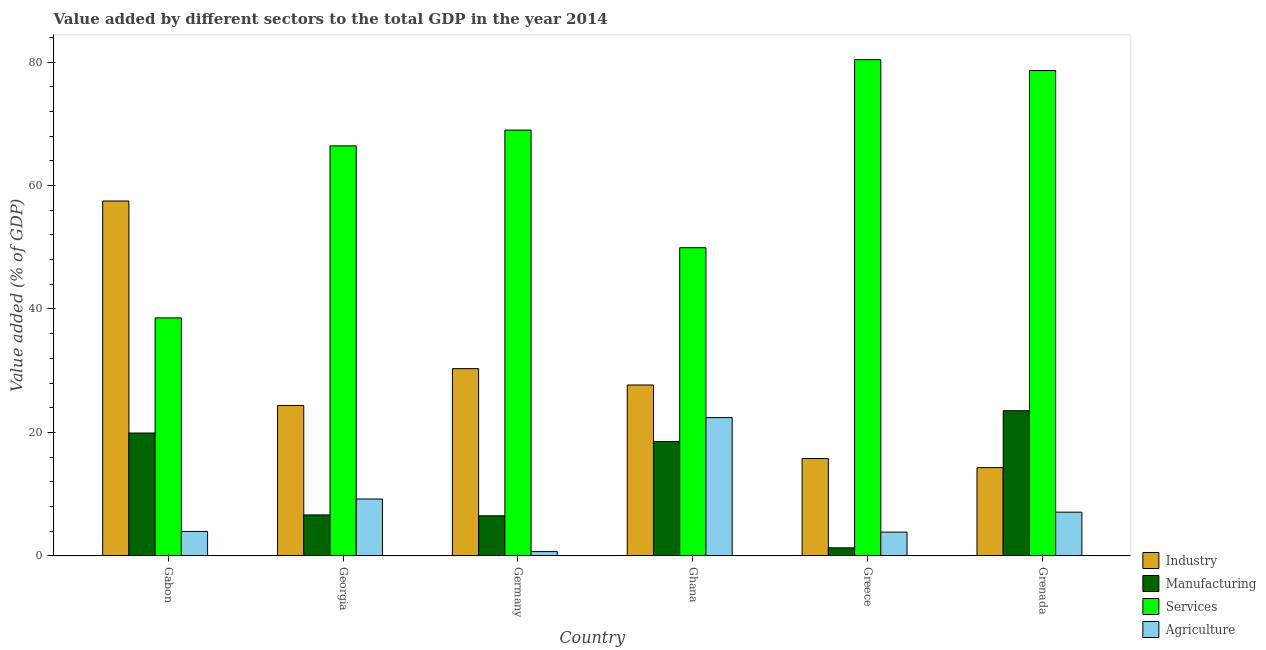How many different coloured bars are there?
Ensure brevity in your answer.  4. How many groups of bars are there?
Ensure brevity in your answer.  6. Are the number of bars per tick equal to the number of legend labels?
Provide a succinct answer. Yes. Are the number of bars on each tick of the X-axis equal?
Your response must be concise. Yes. How many bars are there on the 3rd tick from the right?
Offer a very short reply. 4. What is the label of the 3rd group of bars from the left?
Offer a very short reply. Germany. What is the value added by services sector in Grenada?
Offer a terse response. 78.64. Across all countries, what is the maximum value added by industrial sector?
Your response must be concise. 57.5. Across all countries, what is the minimum value added by industrial sector?
Provide a succinct answer. 14.29. In which country was the value added by manufacturing sector maximum?
Provide a short and direct response. Grenada. In which country was the value added by industrial sector minimum?
Your response must be concise. Grenada. What is the total value added by agricultural sector in the graph?
Your answer should be very brief. 47.14. What is the difference between the value added by services sector in Georgia and that in Grenada?
Your answer should be very brief. -12.21. What is the difference between the value added by manufacturing sector in Grenada and the value added by agricultural sector in Georgia?
Your answer should be very brief. 14.31. What is the average value added by services sector per country?
Keep it short and to the point. 63.82. What is the difference between the value added by agricultural sector and value added by manufacturing sector in Germany?
Offer a very short reply. -5.8. What is the ratio of the value added by industrial sector in Germany to that in Grenada?
Keep it short and to the point. 2.12. Is the difference between the value added by services sector in Germany and Ghana greater than the difference between the value added by manufacturing sector in Germany and Ghana?
Provide a succinct answer. Yes. What is the difference between the highest and the second highest value added by industrial sector?
Ensure brevity in your answer.  27.17. What is the difference between the highest and the lowest value added by services sector?
Make the answer very short. 41.85. In how many countries, is the value added by services sector greater than the average value added by services sector taken over all countries?
Your response must be concise. 4. Is the sum of the value added by agricultural sector in Georgia and Greece greater than the maximum value added by services sector across all countries?
Offer a very short reply. No. Is it the case that in every country, the sum of the value added by agricultural sector and value added by manufacturing sector is greater than the sum of value added by industrial sector and value added by services sector?
Offer a very short reply. No. What does the 3rd bar from the left in Ghana represents?
Offer a very short reply. Services. What does the 1st bar from the right in Gabon represents?
Keep it short and to the point. Agriculture. Is it the case that in every country, the sum of the value added by industrial sector and value added by manufacturing sector is greater than the value added by services sector?
Ensure brevity in your answer.  No. How many bars are there?
Ensure brevity in your answer.  24. Are all the bars in the graph horizontal?
Ensure brevity in your answer.  No. How many countries are there in the graph?
Offer a terse response. 6. Are the values on the major ticks of Y-axis written in scientific E-notation?
Your answer should be compact. No. Does the graph contain any zero values?
Your answer should be very brief. No. Where does the legend appear in the graph?
Your answer should be compact. Bottom right. What is the title of the graph?
Make the answer very short. Value added by different sectors to the total GDP in the year 2014. Does "Greece" appear as one of the legend labels in the graph?
Your response must be concise. No. What is the label or title of the Y-axis?
Make the answer very short. Value added (% of GDP). What is the Value added (% of GDP) of Industry in Gabon?
Give a very brief answer. 57.5. What is the Value added (% of GDP) in Manufacturing in Gabon?
Provide a short and direct response. 19.9. What is the Value added (% of GDP) of Services in Gabon?
Make the answer very short. 38.55. What is the Value added (% of GDP) of Agriculture in Gabon?
Offer a very short reply. 3.95. What is the Value added (% of GDP) in Industry in Georgia?
Your response must be concise. 24.37. What is the Value added (% of GDP) of Manufacturing in Georgia?
Your response must be concise. 6.63. What is the Value added (% of GDP) of Services in Georgia?
Provide a short and direct response. 66.43. What is the Value added (% of GDP) in Agriculture in Georgia?
Your answer should be compact. 9.2. What is the Value added (% of GDP) of Industry in Germany?
Your answer should be compact. 30.33. What is the Value added (% of GDP) of Manufacturing in Germany?
Make the answer very short. 6.48. What is the Value added (% of GDP) of Services in Germany?
Offer a terse response. 68.99. What is the Value added (% of GDP) of Agriculture in Germany?
Give a very brief answer. 0.68. What is the Value added (% of GDP) in Industry in Ghana?
Your answer should be very brief. 27.68. What is the Value added (% of GDP) of Manufacturing in Ghana?
Keep it short and to the point. 18.52. What is the Value added (% of GDP) in Services in Ghana?
Your answer should be compact. 49.93. What is the Value added (% of GDP) of Agriculture in Ghana?
Your answer should be very brief. 22.4. What is the Value added (% of GDP) of Industry in Greece?
Provide a succinct answer. 15.76. What is the Value added (% of GDP) of Manufacturing in Greece?
Make the answer very short. 1.29. What is the Value added (% of GDP) of Services in Greece?
Offer a terse response. 80.4. What is the Value added (% of GDP) in Agriculture in Greece?
Make the answer very short. 3.84. What is the Value added (% of GDP) of Industry in Grenada?
Provide a short and direct response. 14.29. What is the Value added (% of GDP) of Manufacturing in Grenada?
Offer a very short reply. 23.51. What is the Value added (% of GDP) of Services in Grenada?
Your answer should be compact. 78.64. What is the Value added (% of GDP) in Agriculture in Grenada?
Provide a short and direct response. 7.07. Across all countries, what is the maximum Value added (% of GDP) of Industry?
Your response must be concise. 57.5. Across all countries, what is the maximum Value added (% of GDP) in Manufacturing?
Offer a very short reply. 23.51. Across all countries, what is the maximum Value added (% of GDP) in Services?
Keep it short and to the point. 80.4. Across all countries, what is the maximum Value added (% of GDP) of Agriculture?
Provide a succinct answer. 22.4. Across all countries, what is the minimum Value added (% of GDP) in Industry?
Give a very brief answer. 14.29. Across all countries, what is the minimum Value added (% of GDP) in Manufacturing?
Your answer should be compact. 1.29. Across all countries, what is the minimum Value added (% of GDP) in Services?
Your answer should be compact. 38.55. Across all countries, what is the minimum Value added (% of GDP) in Agriculture?
Offer a terse response. 0.68. What is the total Value added (% of GDP) in Industry in the graph?
Your answer should be very brief. 169.92. What is the total Value added (% of GDP) of Manufacturing in the graph?
Provide a short and direct response. 76.33. What is the total Value added (% of GDP) in Services in the graph?
Provide a short and direct response. 382.94. What is the total Value added (% of GDP) of Agriculture in the graph?
Give a very brief answer. 47.14. What is the difference between the Value added (% of GDP) of Industry in Gabon and that in Georgia?
Give a very brief answer. 33.13. What is the difference between the Value added (% of GDP) in Manufacturing in Gabon and that in Georgia?
Give a very brief answer. 13.27. What is the difference between the Value added (% of GDP) of Services in Gabon and that in Georgia?
Your response must be concise. -27.88. What is the difference between the Value added (% of GDP) of Agriculture in Gabon and that in Georgia?
Offer a terse response. -5.25. What is the difference between the Value added (% of GDP) in Industry in Gabon and that in Germany?
Your answer should be compact. 27.17. What is the difference between the Value added (% of GDP) in Manufacturing in Gabon and that in Germany?
Make the answer very short. 13.41. What is the difference between the Value added (% of GDP) in Services in Gabon and that in Germany?
Ensure brevity in your answer.  -30.44. What is the difference between the Value added (% of GDP) of Agriculture in Gabon and that in Germany?
Your answer should be very brief. 3.27. What is the difference between the Value added (% of GDP) in Industry in Gabon and that in Ghana?
Your answer should be compact. 29.82. What is the difference between the Value added (% of GDP) in Manufacturing in Gabon and that in Ghana?
Offer a terse response. 1.37. What is the difference between the Value added (% of GDP) of Services in Gabon and that in Ghana?
Provide a short and direct response. -11.38. What is the difference between the Value added (% of GDP) of Agriculture in Gabon and that in Ghana?
Ensure brevity in your answer.  -18.45. What is the difference between the Value added (% of GDP) of Industry in Gabon and that in Greece?
Provide a succinct answer. 41.74. What is the difference between the Value added (% of GDP) of Manufacturing in Gabon and that in Greece?
Make the answer very short. 18.6. What is the difference between the Value added (% of GDP) of Services in Gabon and that in Greece?
Offer a terse response. -41.85. What is the difference between the Value added (% of GDP) in Agriculture in Gabon and that in Greece?
Provide a short and direct response. 0.11. What is the difference between the Value added (% of GDP) of Industry in Gabon and that in Grenada?
Offer a very short reply. 43.21. What is the difference between the Value added (% of GDP) in Manufacturing in Gabon and that in Grenada?
Your answer should be very brief. -3.62. What is the difference between the Value added (% of GDP) in Services in Gabon and that in Grenada?
Ensure brevity in your answer.  -40.09. What is the difference between the Value added (% of GDP) of Agriculture in Gabon and that in Grenada?
Offer a terse response. -3.12. What is the difference between the Value added (% of GDP) in Industry in Georgia and that in Germany?
Offer a terse response. -5.96. What is the difference between the Value added (% of GDP) of Manufacturing in Georgia and that in Germany?
Offer a very short reply. 0.14. What is the difference between the Value added (% of GDP) of Services in Georgia and that in Germany?
Your answer should be compact. -2.56. What is the difference between the Value added (% of GDP) of Agriculture in Georgia and that in Germany?
Your answer should be compact. 8.52. What is the difference between the Value added (% of GDP) in Industry in Georgia and that in Ghana?
Keep it short and to the point. -3.31. What is the difference between the Value added (% of GDP) in Manufacturing in Georgia and that in Ghana?
Offer a very short reply. -11.9. What is the difference between the Value added (% of GDP) of Services in Georgia and that in Ghana?
Provide a succinct answer. 16.5. What is the difference between the Value added (% of GDP) of Agriculture in Georgia and that in Ghana?
Give a very brief answer. -13.19. What is the difference between the Value added (% of GDP) of Industry in Georgia and that in Greece?
Make the answer very short. 8.61. What is the difference between the Value added (% of GDP) of Manufacturing in Georgia and that in Greece?
Offer a very short reply. 5.33. What is the difference between the Value added (% of GDP) of Services in Georgia and that in Greece?
Give a very brief answer. -13.97. What is the difference between the Value added (% of GDP) of Agriculture in Georgia and that in Greece?
Make the answer very short. 5.37. What is the difference between the Value added (% of GDP) in Industry in Georgia and that in Grenada?
Provide a succinct answer. 10.08. What is the difference between the Value added (% of GDP) of Manufacturing in Georgia and that in Grenada?
Your answer should be compact. -16.89. What is the difference between the Value added (% of GDP) of Services in Georgia and that in Grenada?
Ensure brevity in your answer.  -12.21. What is the difference between the Value added (% of GDP) of Agriculture in Georgia and that in Grenada?
Your response must be concise. 2.13. What is the difference between the Value added (% of GDP) in Industry in Germany and that in Ghana?
Your answer should be very brief. 2.65. What is the difference between the Value added (% of GDP) in Manufacturing in Germany and that in Ghana?
Offer a terse response. -12.04. What is the difference between the Value added (% of GDP) of Services in Germany and that in Ghana?
Your answer should be very brief. 19.06. What is the difference between the Value added (% of GDP) in Agriculture in Germany and that in Ghana?
Offer a very short reply. -21.71. What is the difference between the Value added (% of GDP) in Industry in Germany and that in Greece?
Provide a short and direct response. 14.57. What is the difference between the Value added (% of GDP) of Manufacturing in Germany and that in Greece?
Keep it short and to the point. 5.19. What is the difference between the Value added (% of GDP) of Services in Germany and that in Greece?
Give a very brief answer. -11.41. What is the difference between the Value added (% of GDP) of Agriculture in Germany and that in Greece?
Your response must be concise. -3.16. What is the difference between the Value added (% of GDP) in Industry in Germany and that in Grenada?
Ensure brevity in your answer.  16.04. What is the difference between the Value added (% of GDP) in Manufacturing in Germany and that in Grenada?
Provide a short and direct response. -17.03. What is the difference between the Value added (% of GDP) in Services in Germany and that in Grenada?
Ensure brevity in your answer.  -9.65. What is the difference between the Value added (% of GDP) of Agriculture in Germany and that in Grenada?
Offer a very short reply. -6.39. What is the difference between the Value added (% of GDP) in Industry in Ghana and that in Greece?
Keep it short and to the point. 11.92. What is the difference between the Value added (% of GDP) in Manufacturing in Ghana and that in Greece?
Offer a terse response. 17.23. What is the difference between the Value added (% of GDP) in Services in Ghana and that in Greece?
Your answer should be very brief. -30.47. What is the difference between the Value added (% of GDP) in Agriculture in Ghana and that in Greece?
Your answer should be compact. 18.56. What is the difference between the Value added (% of GDP) in Industry in Ghana and that in Grenada?
Make the answer very short. 13.39. What is the difference between the Value added (% of GDP) in Manufacturing in Ghana and that in Grenada?
Your answer should be compact. -4.99. What is the difference between the Value added (% of GDP) of Services in Ghana and that in Grenada?
Offer a very short reply. -28.72. What is the difference between the Value added (% of GDP) of Agriculture in Ghana and that in Grenada?
Make the answer very short. 15.33. What is the difference between the Value added (% of GDP) in Industry in Greece and that in Grenada?
Your answer should be very brief. 1.47. What is the difference between the Value added (% of GDP) in Manufacturing in Greece and that in Grenada?
Offer a terse response. -22.22. What is the difference between the Value added (% of GDP) in Services in Greece and that in Grenada?
Your answer should be compact. 1.76. What is the difference between the Value added (% of GDP) in Agriculture in Greece and that in Grenada?
Keep it short and to the point. -3.23. What is the difference between the Value added (% of GDP) in Industry in Gabon and the Value added (% of GDP) in Manufacturing in Georgia?
Provide a succinct answer. 50.87. What is the difference between the Value added (% of GDP) of Industry in Gabon and the Value added (% of GDP) of Services in Georgia?
Ensure brevity in your answer.  -8.93. What is the difference between the Value added (% of GDP) of Industry in Gabon and the Value added (% of GDP) of Agriculture in Georgia?
Ensure brevity in your answer.  48.3. What is the difference between the Value added (% of GDP) in Manufacturing in Gabon and the Value added (% of GDP) in Services in Georgia?
Provide a short and direct response. -46.54. What is the difference between the Value added (% of GDP) in Manufacturing in Gabon and the Value added (% of GDP) in Agriculture in Georgia?
Your answer should be very brief. 10.69. What is the difference between the Value added (% of GDP) in Services in Gabon and the Value added (% of GDP) in Agriculture in Georgia?
Ensure brevity in your answer.  29.35. What is the difference between the Value added (% of GDP) of Industry in Gabon and the Value added (% of GDP) of Manufacturing in Germany?
Offer a terse response. 51.02. What is the difference between the Value added (% of GDP) of Industry in Gabon and the Value added (% of GDP) of Services in Germany?
Offer a terse response. -11.49. What is the difference between the Value added (% of GDP) of Industry in Gabon and the Value added (% of GDP) of Agriculture in Germany?
Your response must be concise. 56.82. What is the difference between the Value added (% of GDP) in Manufacturing in Gabon and the Value added (% of GDP) in Services in Germany?
Your answer should be compact. -49.09. What is the difference between the Value added (% of GDP) in Manufacturing in Gabon and the Value added (% of GDP) in Agriculture in Germany?
Provide a short and direct response. 19.21. What is the difference between the Value added (% of GDP) in Services in Gabon and the Value added (% of GDP) in Agriculture in Germany?
Provide a short and direct response. 37.87. What is the difference between the Value added (% of GDP) of Industry in Gabon and the Value added (% of GDP) of Manufacturing in Ghana?
Provide a succinct answer. 38.98. What is the difference between the Value added (% of GDP) of Industry in Gabon and the Value added (% of GDP) of Services in Ghana?
Your response must be concise. 7.57. What is the difference between the Value added (% of GDP) in Industry in Gabon and the Value added (% of GDP) in Agriculture in Ghana?
Offer a very short reply. 35.1. What is the difference between the Value added (% of GDP) in Manufacturing in Gabon and the Value added (% of GDP) in Services in Ghana?
Offer a terse response. -30.03. What is the difference between the Value added (% of GDP) of Manufacturing in Gabon and the Value added (% of GDP) of Agriculture in Ghana?
Provide a succinct answer. -2.5. What is the difference between the Value added (% of GDP) in Services in Gabon and the Value added (% of GDP) in Agriculture in Ghana?
Offer a very short reply. 16.15. What is the difference between the Value added (% of GDP) in Industry in Gabon and the Value added (% of GDP) in Manufacturing in Greece?
Your answer should be very brief. 56.21. What is the difference between the Value added (% of GDP) of Industry in Gabon and the Value added (% of GDP) of Services in Greece?
Provide a short and direct response. -22.9. What is the difference between the Value added (% of GDP) of Industry in Gabon and the Value added (% of GDP) of Agriculture in Greece?
Ensure brevity in your answer.  53.66. What is the difference between the Value added (% of GDP) of Manufacturing in Gabon and the Value added (% of GDP) of Services in Greece?
Provide a succinct answer. -60.51. What is the difference between the Value added (% of GDP) in Manufacturing in Gabon and the Value added (% of GDP) in Agriculture in Greece?
Provide a short and direct response. 16.06. What is the difference between the Value added (% of GDP) of Services in Gabon and the Value added (% of GDP) of Agriculture in Greece?
Ensure brevity in your answer.  34.71. What is the difference between the Value added (% of GDP) of Industry in Gabon and the Value added (% of GDP) of Manufacturing in Grenada?
Ensure brevity in your answer.  33.99. What is the difference between the Value added (% of GDP) in Industry in Gabon and the Value added (% of GDP) in Services in Grenada?
Offer a terse response. -21.14. What is the difference between the Value added (% of GDP) of Industry in Gabon and the Value added (% of GDP) of Agriculture in Grenada?
Your answer should be very brief. 50.43. What is the difference between the Value added (% of GDP) of Manufacturing in Gabon and the Value added (% of GDP) of Services in Grenada?
Provide a succinct answer. -58.75. What is the difference between the Value added (% of GDP) in Manufacturing in Gabon and the Value added (% of GDP) in Agriculture in Grenada?
Provide a succinct answer. 12.83. What is the difference between the Value added (% of GDP) in Services in Gabon and the Value added (% of GDP) in Agriculture in Grenada?
Give a very brief answer. 31.48. What is the difference between the Value added (% of GDP) in Industry in Georgia and the Value added (% of GDP) in Manufacturing in Germany?
Keep it short and to the point. 17.88. What is the difference between the Value added (% of GDP) in Industry in Georgia and the Value added (% of GDP) in Services in Germany?
Offer a very short reply. -44.62. What is the difference between the Value added (% of GDP) in Industry in Georgia and the Value added (% of GDP) in Agriculture in Germany?
Give a very brief answer. 23.68. What is the difference between the Value added (% of GDP) of Manufacturing in Georgia and the Value added (% of GDP) of Services in Germany?
Provide a succinct answer. -62.36. What is the difference between the Value added (% of GDP) in Manufacturing in Georgia and the Value added (% of GDP) in Agriculture in Germany?
Offer a terse response. 5.94. What is the difference between the Value added (% of GDP) in Services in Georgia and the Value added (% of GDP) in Agriculture in Germany?
Offer a very short reply. 65.75. What is the difference between the Value added (% of GDP) of Industry in Georgia and the Value added (% of GDP) of Manufacturing in Ghana?
Provide a short and direct response. 5.84. What is the difference between the Value added (% of GDP) of Industry in Georgia and the Value added (% of GDP) of Services in Ghana?
Ensure brevity in your answer.  -25.56. What is the difference between the Value added (% of GDP) of Industry in Georgia and the Value added (% of GDP) of Agriculture in Ghana?
Provide a succinct answer. 1.97. What is the difference between the Value added (% of GDP) of Manufacturing in Georgia and the Value added (% of GDP) of Services in Ghana?
Offer a very short reply. -43.3. What is the difference between the Value added (% of GDP) of Manufacturing in Georgia and the Value added (% of GDP) of Agriculture in Ghana?
Ensure brevity in your answer.  -15.77. What is the difference between the Value added (% of GDP) in Services in Georgia and the Value added (% of GDP) in Agriculture in Ghana?
Offer a terse response. 44.03. What is the difference between the Value added (% of GDP) in Industry in Georgia and the Value added (% of GDP) in Manufacturing in Greece?
Ensure brevity in your answer.  23.07. What is the difference between the Value added (% of GDP) in Industry in Georgia and the Value added (% of GDP) in Services in Greece?
Ensure brevity in your answer.  -56.03. What is the difference between the Value added (% of GDP) of Industry in Georgia and the Value added (% of GDP) of Agriculture in Greece?
Provide a short and direct response. 20.53. What is the difference between the Value added (% of GDP) in Manufacturing in Georgia and the Value added (% of GDP) in Services in Greece?
Your response must be concise. -73.78. What is the difference between the Value added (% of GDP) in Manufacturing in Georgia and the Value added (% of GDP) in Agriculture in Greece?
Your response must be concise. 2.79. What is the difference between the Value added (% of GDP) in Services in Georgia and the Value added (% of GDP) in Agriculture in Greece?
Your answer should be compact. 62.59. What is the difference between the Value added (% of GDP) of Industry in Georgia and the Value added (% of GDP) of Manufacturing in Grenada?
Provide a succinct answer. 0.86. What is the difference between the Value added (% of GDP) of Industry in Georgia and the Value added (% of GDP) of Services in Grenada?
Make the answer very short. -54.28. What is the difference between the Value added (% of GDP) of Industry in Georgia and the Value added (% of GDP) of Agriculture in Grenada?
Provide a succinct answer. 17.3. What is the difference between the Value added (% of GDP) in Manufacturing in Georgia and the Value added (% of GDP) in Services in Grenada?
Offer a terse response. -72.02. What is the difference between the Value added (% of GDP) in Manufacturing in Georgia and the Value added (% of GDP) in Agriculture in Grenada?
Offer a very short reply. -0.44. What is the difference between the Value added (% of GDP) of Services in Georgia and the Value added (% of GDP) of Agriculture in Grenada?
Your answer should be very brief. 59.36. What is the difference between the Value added (% of GDP) in Industry in Germany and the Value added (% of GDP) in Manufacturing in Ghana?
Offer a very short reply. 11.8. What is the difference between the Value added (% of GDP) in Industry in Germany and the Value added (% of GDP) in Services in Ghana?
Your answer should be compact. -19.6. What is the difference between the Value added (% of GDP) of Industry in Germany and the Value added (% of GDP) of Agriculture in Ghana?
Your answer should be very brief. 7.93. What is the difference between the Value added (% of GDP) in Manufacturing in Germany and the Value added (% of GDP) in Services in Ghana?
Offer a terse response. -43.44. What is the difference between the Value added (% of GDP) of Manufacturing in Germany and the Value added (% of GDP) of Agriculture in Ghana?
Offer a very short reply. -15.91. What is the difference between the Value added (% of GDP) in Services in Germany and the Value added (% of GDP) in Agriculture in Ghana?
Offer a terse response. 46.59. What is the difference between the Value added (% of GDP) of Industry in Germany and the Value added (% of GDP) of Manufacturing in Greece?
Give a very brief answer. 29.04. What is the difference between the Value added (% of GDP) of Industry in Germany and the Value added (% of GDP) of Services in Greece?
Your answer should be compact. -50.07. What is the difference between the Value added (% of GDP) in Industry in Germany and the Value added (% of GDP) in Agriculture in Greece?
Your response must be concise. 26.49. What is the difference between the Value added (% of GDP) of Manufacturing in Germany and the Value added (% of GDP) of Services in Greece?
Offer a terse response. -73.92. What is the difference between the Value added (% of GDP) of Manufacturing in Germany and the Value added (% of GDP) of Agriculture in Greece?
Provide a succinct answer. 2.65. What is the difference between the Value added (% of GDP) of Services in Germany and the Value added (% of GDP) of Agriculture in Greece?
Offer a very short reply. 65.15. What is the difference between the Value added (% of GDP) of Industry in Germany and the Value added (% of GDP) of Manufacturing in Grenada?
Provide a short and direct response. 6.82. What is the difference between the Value added (% of GDP) in Industry in Germany and the Value added (% of GDP) in Services in Grenada?
Keep it short and to the point. -48.32. What is the difference between the Value added (% of GDP) of Industry in Germany and the Value added (% of GDP) of Agriculture in Grenada?
Your answer should be compact. 23.26. What is the difference between the Value added (% of GDP) of Manufacturing in Germany and the Value added (% of GDP) of Services in Grenada?
Your answer should be very brief. -72.16. What is the difference between the Value added (% of GDP) in Manufacturing in Germany and the Value added (% of GDP) in Agriculture in Grenada?
Give a very brief answer. -0.59. What is the difference between the Value added (% of GDP) of Services in Germany and the Value added (% of GDP) of Agriculture in Grenada?
Provide a short and direct response. 61.92. What is the difference between the Value added (% of GDP) in Industry in Ghana and the Value added (% of GDP) in Manufacturing in Greece?
Give a very brief answer. 26.38. What is the difference between the Value added (% of GDP) in Industry in Ghana and the Value added (% of GDP) in Services in Greece?
Provide a short and direct response. -52.72. What is the difference between the Value added (% of GDP) in Industry in Ghana and the Value added (% of GDP) in Agriculture in Greece?
Make the answer very short. 23.84. What is the difference between the Value added (% of GDP) in Manufacturing in Ghana and the Value added (% of GDP) in Services in Greece?
Provide a succinct answer. -61.88. What is the difference between the Value added (% of GDP) of Manufacturing in Ghana and the Value added (% of GDP) of Agriculture in Greece?
Your answer should be compact. 14.69. What is the difference between the Value added (% of GDP) of Services in Ghana and the Value added (% of GDP) of Agriculture in Greece?
Offer a very short reply. 46.09. What is the difference between the Value added (% of GDP) in Industry in Ghana and the Value added (% of GDP) in Manufacturing in Grenada?
Your response must be concise. 4.17. What is the difference between the Value added (% of GDP) of Industry in Ghana and the Value added (% of GDP) of Services in Grenada?
Make the answer very short. -50.97. What is the difference between the Value added (% of GDP) of Industry in Ghana and the Value added (% of GDP) of Agriculture in Grenada?
Keep it short and to the point. 20.61. What is the difference between the Value added (% of GDP) of Manufacturing in Ghana and the Value added (% of GDP) of Services in Grenada?
Your answer should be very brief. -60.12. What is the difference between the Value added (% of GDP) in Manufacturing in Ghana and the Value added (% of GDP) in Agriculture in Grenada?
Give a very brief answer. 11.45. What is the difference between the Value added (% of GDP) in Services in Ghana and the Value added (% of GDP) in Agriculture in Grenada?
Offer a very short reply. 42.86. What is the difference between the Value added (% of GDP) of Industry in Greece and the Value added (% of GDP) of Manufacturing in Grenada?
Keep it short and to the point. -7.75. What is the difference between the Value added (% of GDP) in Industry in Greece and the Value added (% of GDP) in Services in Grenada?
Provide a succinct answer. -62.88. What is the difference between the Value added (% of GDP) in Industry in Greece and the Value added (% of GDP) in Agriculture in Grenada?
Your answer should be compact. 8.69. What is the difference between the Value added (% of GDP) in Manufacturing in Greece and the Value added (% of GDP) in Services in Grenada?
Offer a terse response. -77.35. What is the difference between the Value added (% of GDP) in Manufacturing in Greece and the Value added (% of GDP) in Agriculture in Grenada?
Your response must be concise. -5.78. What is the difference between the Value added (% of GDP) of Services in Greece and the Value added (% of GDP) of Agriculture in Grenada?
Keep it short and to the point. 73.33. What is the average Value added (% of GDP) of Industry per country?
Give a very brief answer. 28.32. What is the average Value added (% of GDP) in Manufacturing per country?
Keep it short and to the point. 12.72. What is the average Value added (% of GDP) of Services per country?
Your answer should be very brief. 63.82. What is the average Value added (% of GDP) in Agriculture per country?
Provide a short and direct response. 7.86. What is the difference between the Value added (% of GDP) of Industry and Value added (% of GDP) of Manufacturing in Gabon?
Offer a terse response. 37.6. What is the difference between the Value added (% of GDP) of Industry and Value added (% of GDP) of Services in Gabon?
Make the answer very short. 18.95. What is the difference between the Value added (% of GDP) of Industry and Value added (% of GDP) of Agriculture in Gabon?
Your answer should be very brief. 53.55. What is the difference between the Value added (% of GDP) in Manufacturing and Value added (% of GDP) in Services in Gabon?
Your answer should be compact. -18.66. What is the difference between the Value added (% of GDP) of Manufacturing and Value added (% of GDP) of Agriculture in Gabon?
Provide a succinct answer. 15.95. What is the difference between the Value added (% of GDP) in Services and Value added (% of GDP) in Agriculture in Gabon?
Your answer should be compact. 34.6. What is the difference between the Value added (% of GDP) of Industry and Value added (% of GDP) of Manufacturing in Georgia?
Offer a very short reply. 17.74. What is the difference between the Value added (% of GDP) in Industry and Value added (% of GDP) in Services in Georgia?
Give a very brief answer. -42.06. What is the difference between the Value added (% of GDP) of Industry and Value added (% of GDP) of Agriculture in Georgia?
Provide a succinct answer. 15.16. What is the difference between the Value added (% of GDP) of Manufacturing and Value added (% of GDP) of Services in Georgia?
Keep it short and to the point. -59.81. What is the difference between the Value added (% of GDP) in Manufacturing and Value added (% of GDP) in Agriculture in Georgia?
Give a very brief answer. -2.58. What is the difference between the Value added (% of GDP) of Services and Value added (% of GDP) of Agriculture in Georgia?
Your answer should be very brief. 57.23. What is the difference between the Value added (% of GDP) of Industry and Value added (% of GDP) of Manufacturing in Germany?
Ensure brevity in your answer.  23.84. What is the difference between the Value added (% of GDP) of Industry and Value added (% of GDP) of Services in Germany?
Your answer should be compact. -38.66. What is the difference between the Value added (% of GDP) in Industry and Value added (% of GDP) in Agriculture in Germany?
Ensure brevity in your answer.  29.65. What is the difference between the Value added (% of GDP) of Manufacturing and Value added (% of GDP) of Services in Germany?
Offer a very short reply. -62.51. What is the difference between the Value added (% of GDP) in Manufacturing and Value added (% of GDP) in Agriculture in Germany?
Provide a short and direct response. 5.8. What is the difference between the Value added (% of GDP) in Services and Value added (% of GDP) in Agriculture in Germany?
Ensure brevity in your answer.  68.31. What is the difference between the Value added (% of GDP) in Industry and Value added (% of GDP) in Manufacturing in Ghana?
Your response must be concise. 9.15. What is the difference between the Value added (% of GDP) of Industry and Value added (% of GDP) of Services in Ghana?
Offer a terse response. -22.25. What is the difference between the Value added (% of GDP) of Industry and Value added (% of GDP) of Agriculture in Ghana?
Provide a succinct answer. 5.28. What is the difference between the Value added (% of GDP) in Manufacturing and Value added (% of GDP) in Services in Ghana?
Make the answer very short. -31.4. What is the difference between the Value added (% of GDP) of Manufacturing and Value added (% of GDP) of Agriculture in Ghana?
Offer a very short reply. -3.87. What is the difference between the Value added (% of GDP) of Services and Value added (% of GDP) of Agriculture in Ghana?
Offer a very short reply. 27.53. What is the difference between the Value added (% of GDP) of Industry and Value added (% of GDP) of Manufacturing in Greece?
Offer a very short reply. 14.47. What is the difference between the Value added (% of GDP) in Industry and Value added (% of GDP) in Services in Greece?
Give a very brief answer. -64.64. What is the difference between the Value added (% of GDP) in Industry and Value added (% of GDP) in Agriculture in Greece?
Your answer should be compact. 11.92. What is the difference between the Value added (% of GDP) in Manufacturing and Value added (% of GDP) in Services in Greece?
Provide a short and direct response. -79.11. What is the difference between the Value added (% of GDP) of Manufacturing and Value added (% of GDP) of Agriculture in Greece?
Your answer should be compact. -2.55. What is the difference between the Value added (% of GDP) of Services and Value added (% of GDP) of Agriculture in Greece?
Offer a terse response. 76.56. What is the difference between the Value added (% of GDP) of Industry and Value added (% of GDP) of Manufacturing in Grenada?
Provide a short and direct response. -9.22. What is the difference between the Value added (% of GDP) of Industry and Value added (% of GDP) of Services in Grenada?
Offer a terse response. -64.36. What is the difference between the Value added (% of GDP) of Industry and Value added (% of GDP) of Agriculture in Grenada?
Offer a very short reply. 7.22. What is the difference between the Value added (% of GDP) of Manufacturing and Value added (% of GDP) of Services in Grenada?
Keep it short and to the point. -55.13. What is the difference between the Value added (% of GDP) of Manufacturing and Value added (% of GDP) of Agriculture in Grenada?
Provide a succinct answer. 16.44. What is the difference between the Value added (% of GDP) of Services and Value added (% of GDP) of Agriculture in Grenada?
Offer a terse response. 71.57. What is the ratio of the Value added (% of GDP) of Industry in Gabon to that in Georgia?
Provide a short and direct response. 2.36. What is the ratio of the Value added (% of GDP) in Manufacturing in Gabon to that in Georgia?
Give a very brief answer. 3. What is the ratio of the Value added (% of GDP) in Services in Gabon to that in Georgia?
Offer a very short reply. 0.58. What is the ratio of the Value added (% of GDP) of Agriculture in Gabon to that in Georgia?
Make the answer very short. 0.43. What is the ratio of the Value added (% of GDP) of Industry in Gabon to that in Germany?
Provide a short and direct response. 1.9. What is the ratio of the Value added (% of GDP) of Manufacturing in Gabon to that in Germany?
Offer a very short reply. 3.07. What is the ratio of the Value added (% of GDP) of Services in Gabon to that in Germany?
Provide a succinct answer. 0.56. What is the ratio of the Value added (% of GDP) of Agriculture in Gabon to that in Germany?
Your answer should be very brief. 5.79. What is the ratio of the Value added (% of GDP) in Industry in Gabon to that in Ghana?
Keep it short and to the point. 2.08. What is the ratio of the Value added (% of GDP) in Manufacturing in Gabon to that in Ghana?
Your answer should be very brief. 1.07. What is the ratio of the Value added (% of GDP) of Services in Gabon to that in Ghana?
Keep it short and to the point. 0.77. What is the ratio of the Value added (% of GDP) in Agriculture in Gabon to that in Ghana?
Provide a succinct answer. 0.18. What is the ratio of the Value added (% of GDP) of Industry in Gabon to that in Greece?
Provide a short and direct response. 3.65. What is the ratio of the Value added (% of GDP) of Manufacturing in Gabon to that in Greece?
Your answer should be compact. 15.4. What is the ratio of the Value added (% of GDP) in Services in Gabon to that in Greece?
Provide a succinct answer. 0.48. What is the ratio of the Value added (% of GDP) in Industry in Gabon to that in Grenada?
Make the answer very short. 4.02. What is the ratio of the Value added (% of GDP) of Manufacturing in Gabon to that in Grenada?
Offer a very short reply. 0.85. What is the ratio of the Value added (% of GDP) in Services in Gabon to that in Grenada?
Give a very brief answer. 0.49. What is the ratio of the Value added (% of GDP) in Agriculture in Gabon to that in Grenada?
Your response must be concise. 0.56. What is the ratio of the Value added (% of GDP) in Industry in Georgia to that in Germany?
Ensure brevity in your answer.  0.8. What is the ratio of the Value added (% of GDP) of Manufacturing in Georgia to that in Germany?
Your response must be concise. 1.02. What is the ratio of the Value added (% of GDP) of Services in Georgia to that in Germany?
Your answer should be very brief. 0.96. What is the ratio of the Value added (% of GDP) in Agriculture in Georgia to that in Germany?
Your answer should be very brief. 13.48. What is the ratio of the Value added (% of GDP) of Industry in Georgia to that in Ghana?
Offer a very short reply. 0.88. What is the ratio of the Value added (% of GDP) of Manufacturing in Georgia to that in Ghana?
Keep it short and to the point. 0.36. What is the ratio of the Value added (% of GDP) in Services in Georgia to that in Ghana?
Provide a short and direct response. 1.33. What is the ratio of the Value added (% of GDP) of Agriculture in Georgia to that in Ghana?
Your answer should be very brief. 0.41. What is the ratio of the Value added (% of GDP) of Industry in Georgia to that in Greece?
Make the answer very short. 1.55. What is the ratio of the Value added (% of GDP) of Manufacturing in Georgia to that in Greece?
Ensure brevity in your answer.  5.13. What is the ratio of the Value added (% of GDP) in Services in Georgia to that in Greece?
Your answer should be compact. 0.83. What is the ratio of the Value added (% of GDP) of Agriculture in Georgia to that in Greece?
Provide a short and direct response. 2.4. What is the ratio of the Value added (% of GDP) of Industry in Georgia to that in Grenada?
Provide a short and direct response. 1.71. What is the ratio of the Value added (% of GDP) of Manufacturing in Georgia to that in Grenada?
Your answer should be very brief. 0.28. What is the ratio of the Value added (% of GDP) in Services in Georgia to that in Grenada?
Your response must be concise. 0.84. What is the ratio of the Value added (% of GDP) of Agriculture in Georgia to that in Grenada?
Your answer should be compact. 1.3. What is the ratio of the Value added (% of GDP) in Industry in Germany to that in Ghana?
Your answer should be compact. 1.1. What is the ratio of the Value added (% of GDP) in Manufacturing in Germany to that in Ghana?
Give a very brief answer. 0.35. What is the ratio of the Value added (% of GDP) in Services in Germany to that in Ghana?
Give a very brief answer. 1.38. What is the ratio of the Value added (% of GDP) in Agriculture in Germany to that in Ghana?
Your answer should be compact. 0.03. What is the ratio of the Value added (% of GDP) in Industry in Germany to that in Greece?
Offer a terse response. 1.92. What is the ratio of the Value added (% of GDP) in Manufacturing in Germany to that in Greece?
Your response must be concise. 5.02. What is the ratio of the Value added (% of GDP) in Services in Germany to that in Greece?
Ensure brevity in your answer.  0.86. What is the ratio of the Value added (% of GDP) of Agriculture in Germany to that in Greece?
Your answer should be very brief. 0.18. What is the ratio of the Value added (% of GDP) of Industry in Germany to that in Grenada?
Provide a short and direct response. 2.12. What is the ratio of the Value added (% of GDP) in Manufacturing in Germany to that in Grenada?
Provide a short and direct response. 0.28. What is the ratio of the Value added (% of GDP) of Services in Germany to that in Grenada?
Your answer should be compact. 0.88. What is the ratio of the Value added (% of GDP) in Agriculture in Germany to that in Grenada?
Ensure brevity in your answer.  0.1. What is the ratio of the Value added (% of GDP) in Industry in Ghana to that in Greece?
Offer a terse response. 1.76. What is the ratio of the Value added (% of GDP) in Manufacturing in Ghana to that in Greece?
Offer a terse response. 14.34. What is the ratio of the Value added (% of GDP) in Services in Ghana to that in Greece?
Ensure brevity in your answer.  0.62. What is the ratio of the Value added (% of GDP) in Agriculture in Ghana to that in Greece?
Keep it short and to the point. 5.83. What is the ratio of the Value added (% of GDP) of Industry in Ghana to that in Grenada?
Keep it short and to the point. 1.94. What is the ratio of the Value added (% of GDP) in Manufacturing in Ghana to that in Grenada?
Your answer should be very brief. 0.79. What is the ratio of the Value added (% of GDP) in Services in Ghana to that in Grenada?
Provide a succinct answer. 0.63. What is the ratio of the Value added (% of GDP) in Agriculture in Ghana to that in Grenada?
Your answer should be very brief. 3.17. What is the ratio of the Value added (% of GDP) in Industry in Greece to that in Grenada?
Your answer should be very brief. 1.1. What is the ratio of the Value added (% of GDP) of Manufacturing in Greece to that in Grenada?
Offer a terse response. 0.05. What is the ratio of the Value added (% of GDP) in Services in Greece to that in Grenada?
Keep it short and to the point. 1.02. What is the ratio of the Value added (% of GDP) in Agriculture in Greece to that in Grenada?
Ensure brevity in your answer.  0.54. What is the difference between the highest and the second highest Value added (% of GDP) of Industry?
Your response must be concise. 27.17. What is the difference between the highest and the second highest Value added (% of GDP) of Manufacturing?
Your answer should be compact. 3.62. What is the difference between the highest and the second highest Value added (% of GDP) in Services?
Ensure brevity in your answer.  1.76. What is the difference between the highest and the second highest Value added (% of GDP) in Agriculture?
Ensure brevity in your answer.  13.19. What is the difference between the highest and the lowest Value added (% of GDP) in Industry?
Ensure brevity in your answer.  43.21. What is the difference between the highest and the lowest Value added (% of GDP) of Manufacturing?
Ensure brevity in your answer.  22.22. What is the difference between the highest and the lowest Value added (% of GDP) in Services?
Offer a terse response. 41.85. What is the difference between the highest and the lowest Value added (% of GDP) of Agriculture?
Offer a very short reply. 21.71. 